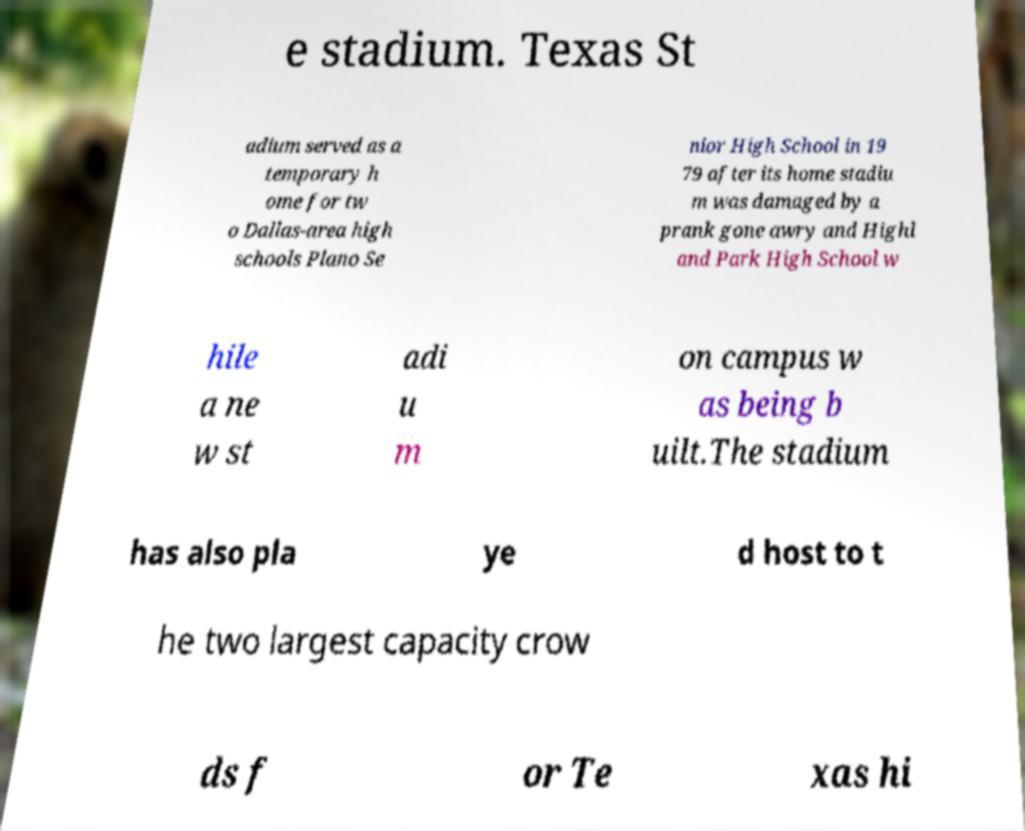Can you accurately transcribe the text from the provided image for me? e stadium. Texas St adium served as a temporary h ome for tw o Dallas-area high schools Plano Se nior High School in 19 79 after its home stadiu m was damaged by a prank gone awry and Highl and Park High School w hile a ne w st adi u m on campus w as being b uilt.The stadium has also pla ye d host to t he two largest capacity crow ds f or Te xas hi 